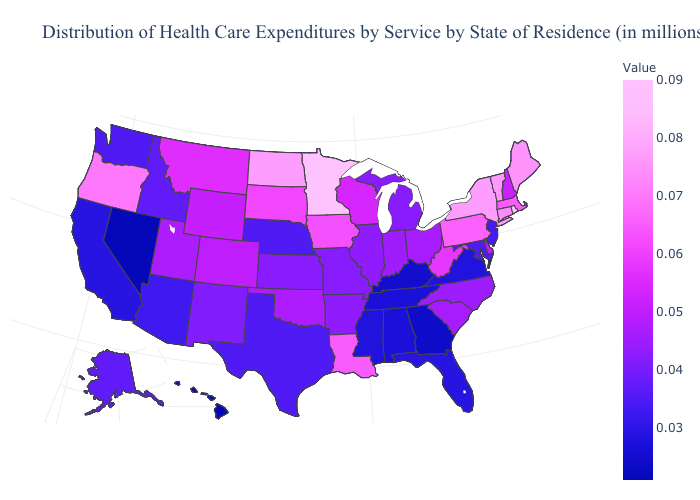Among the states that border Louisiana , does Arkansas have the highest value?
Write a very short answer. Yes. Does Maine have a lower value than Rhode Island?
Short answer required. Yes. Does the map have missing data?
Quick response, please. No. Is the legend a continuous bar?
Be succinct. Yes. Does Minnesota have the highest value in the USA?
Concise answer only. Yes. 